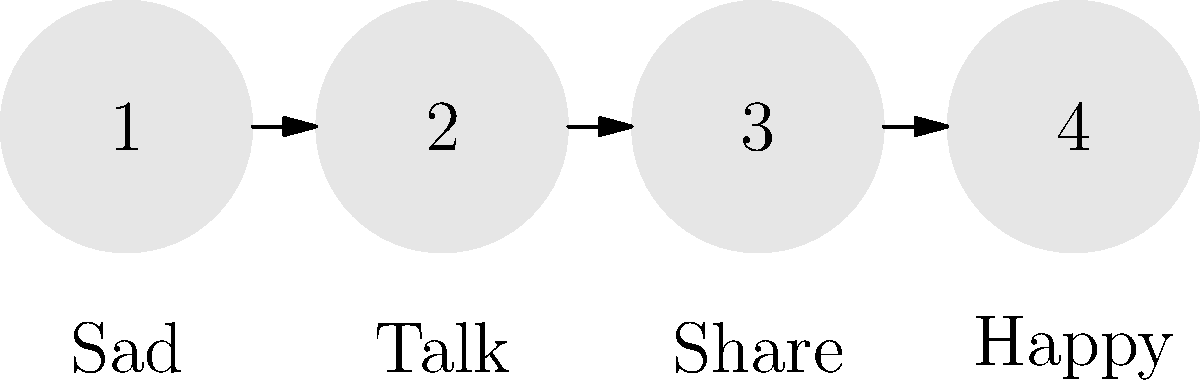Look at the pictures above. They show a story about feeling better when things are hard. What is the right order to put these pictures in to show how someone can feel better? Let's think about this step-by-step:

1. The first picture shows someone feeling sad. This is usually how we feel when we face a challenge, so this should go first.

2. The second picture shows someone talking. When we're sad, it's good to talk to someone we trust, like a friend or grown-up. This helps us feel less alone, so this should go second.

3. The third picture shows sharing. After talking, we might share our feelings or problems. This can help us understand our feelings better and get help, so this goes third.

4. The last picture shows someone feeling happy. After we talk and share, we often feel better and happier. This is the goal, so it should go last.

So, the correct order to show how someone can feel better is:
Sad → Talk → Share → Happy
Answer: 1-2-3-4 